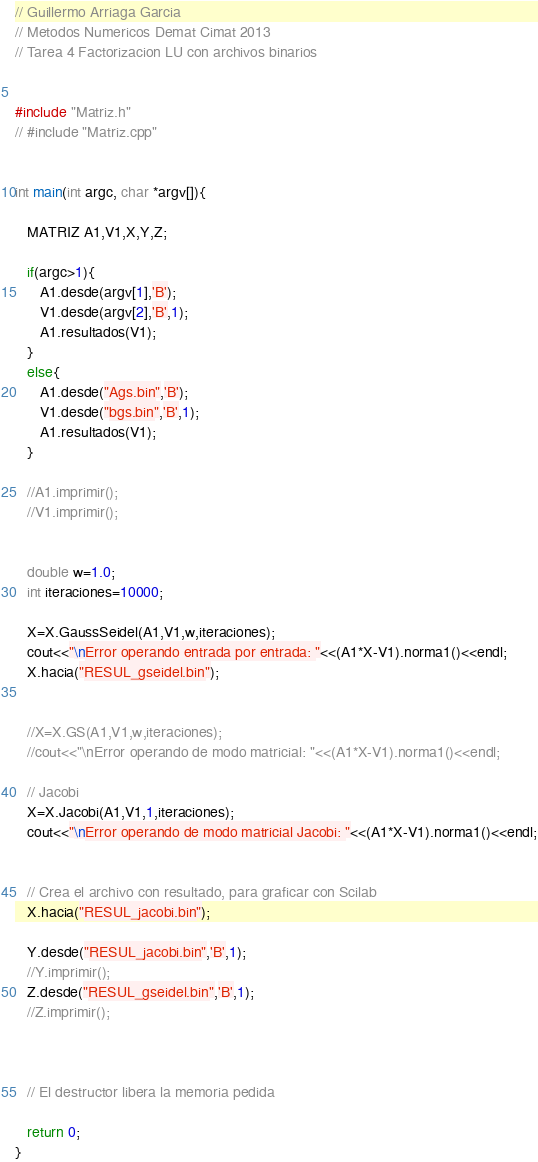<code> <loc_0><loc_0><loc_500><loc_500><_C++_>
// Guillermo Arriaga Garcia
// Metodos Numericos Demat Cimat 2013
// Tarea 4 Factorizacion LU con archivos binarios


#include "Matriz.h"
// #include "Matriz.cpp"


int main(int argc, char *argv[]){

   MATRIZ A1,V1,X,Y,Z;

   if(argc>1){
      A1.desde(argv[1],'B');
      V1.desde(argv[2],'B',1);
      A1.resultados(V1);
   }
   else{
      A1.desde("Ags.bin",'B');
      V1.desde("bgs.bin",'B',1);
      A1.resultados(V1);
   }

   //A1.imprimir();
   //V1.imprimir();


   double w=1.0;
   int iteraciones=10000;

   X=X.GaussSeidel(A1,V1,w,iteraciones);
   cout<<"\nError operando entrada por entrada: "<<(A1*X-V1).norma1()<<endl;
   X.hacia("RESUL_gseidel.bin");


   //X=X.GS(A1,V1,w,iteraciones);
   //cout<<"\nError operando de modo matricial: "<<(A1*X-V1).norma1()<<endl;

   // Jacobi
   X=X.Jacobi(A1,V1,1,iteraciones);
   cout<<"\nError operando de modo matricial Jacobi: "<<(A1*X-V1).norma1()<<endl;


   // Crea el archivo con resultado, para graficar con Scilab
   X.hacia("RESUL_jacobi.bin");

   Y.desde("RESUL_jacobi.bin",'B',1);
   //Y.imprimir();
   Z.desde("RESUL_gseidel.bin",'B',1);
   //Z.imprimir();



   // El destructor libera la memoria pedida

   return 0;
}
</code> 